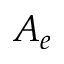Convert formula to latex. <formula><loc_0><loc_0><loc_500><loc_500>A _ { e }</formula> 